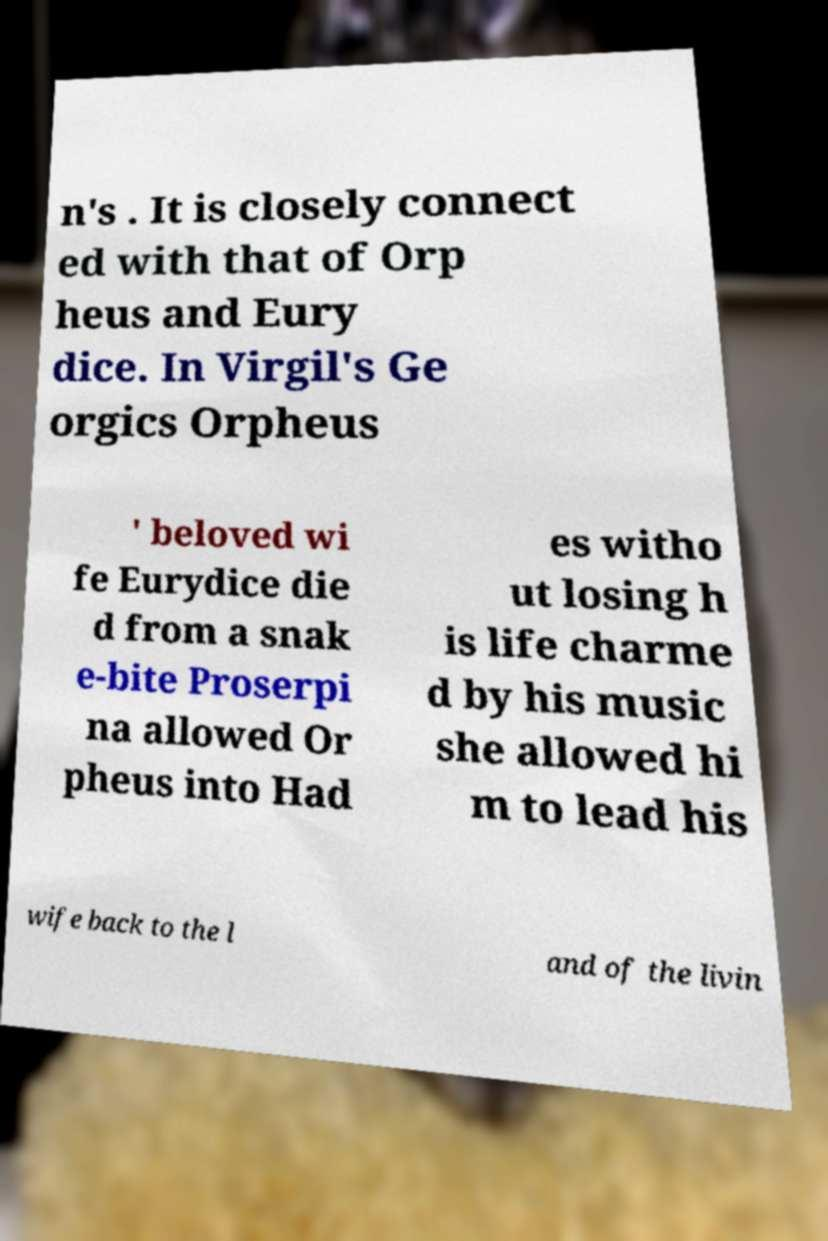Could you extract and type out the text from this image? n's . It is closely connect ed with that of Orp heus and Eury dice. In Virgil's Ge orgics Orpheus ' beloved wi fe Eurydice die d from a snak e-bite Proserpi na allowed Or pheus into Had es witho ut losing h is life charme d by his music she allowed hi m to lead his wife back to the l and of the livin 